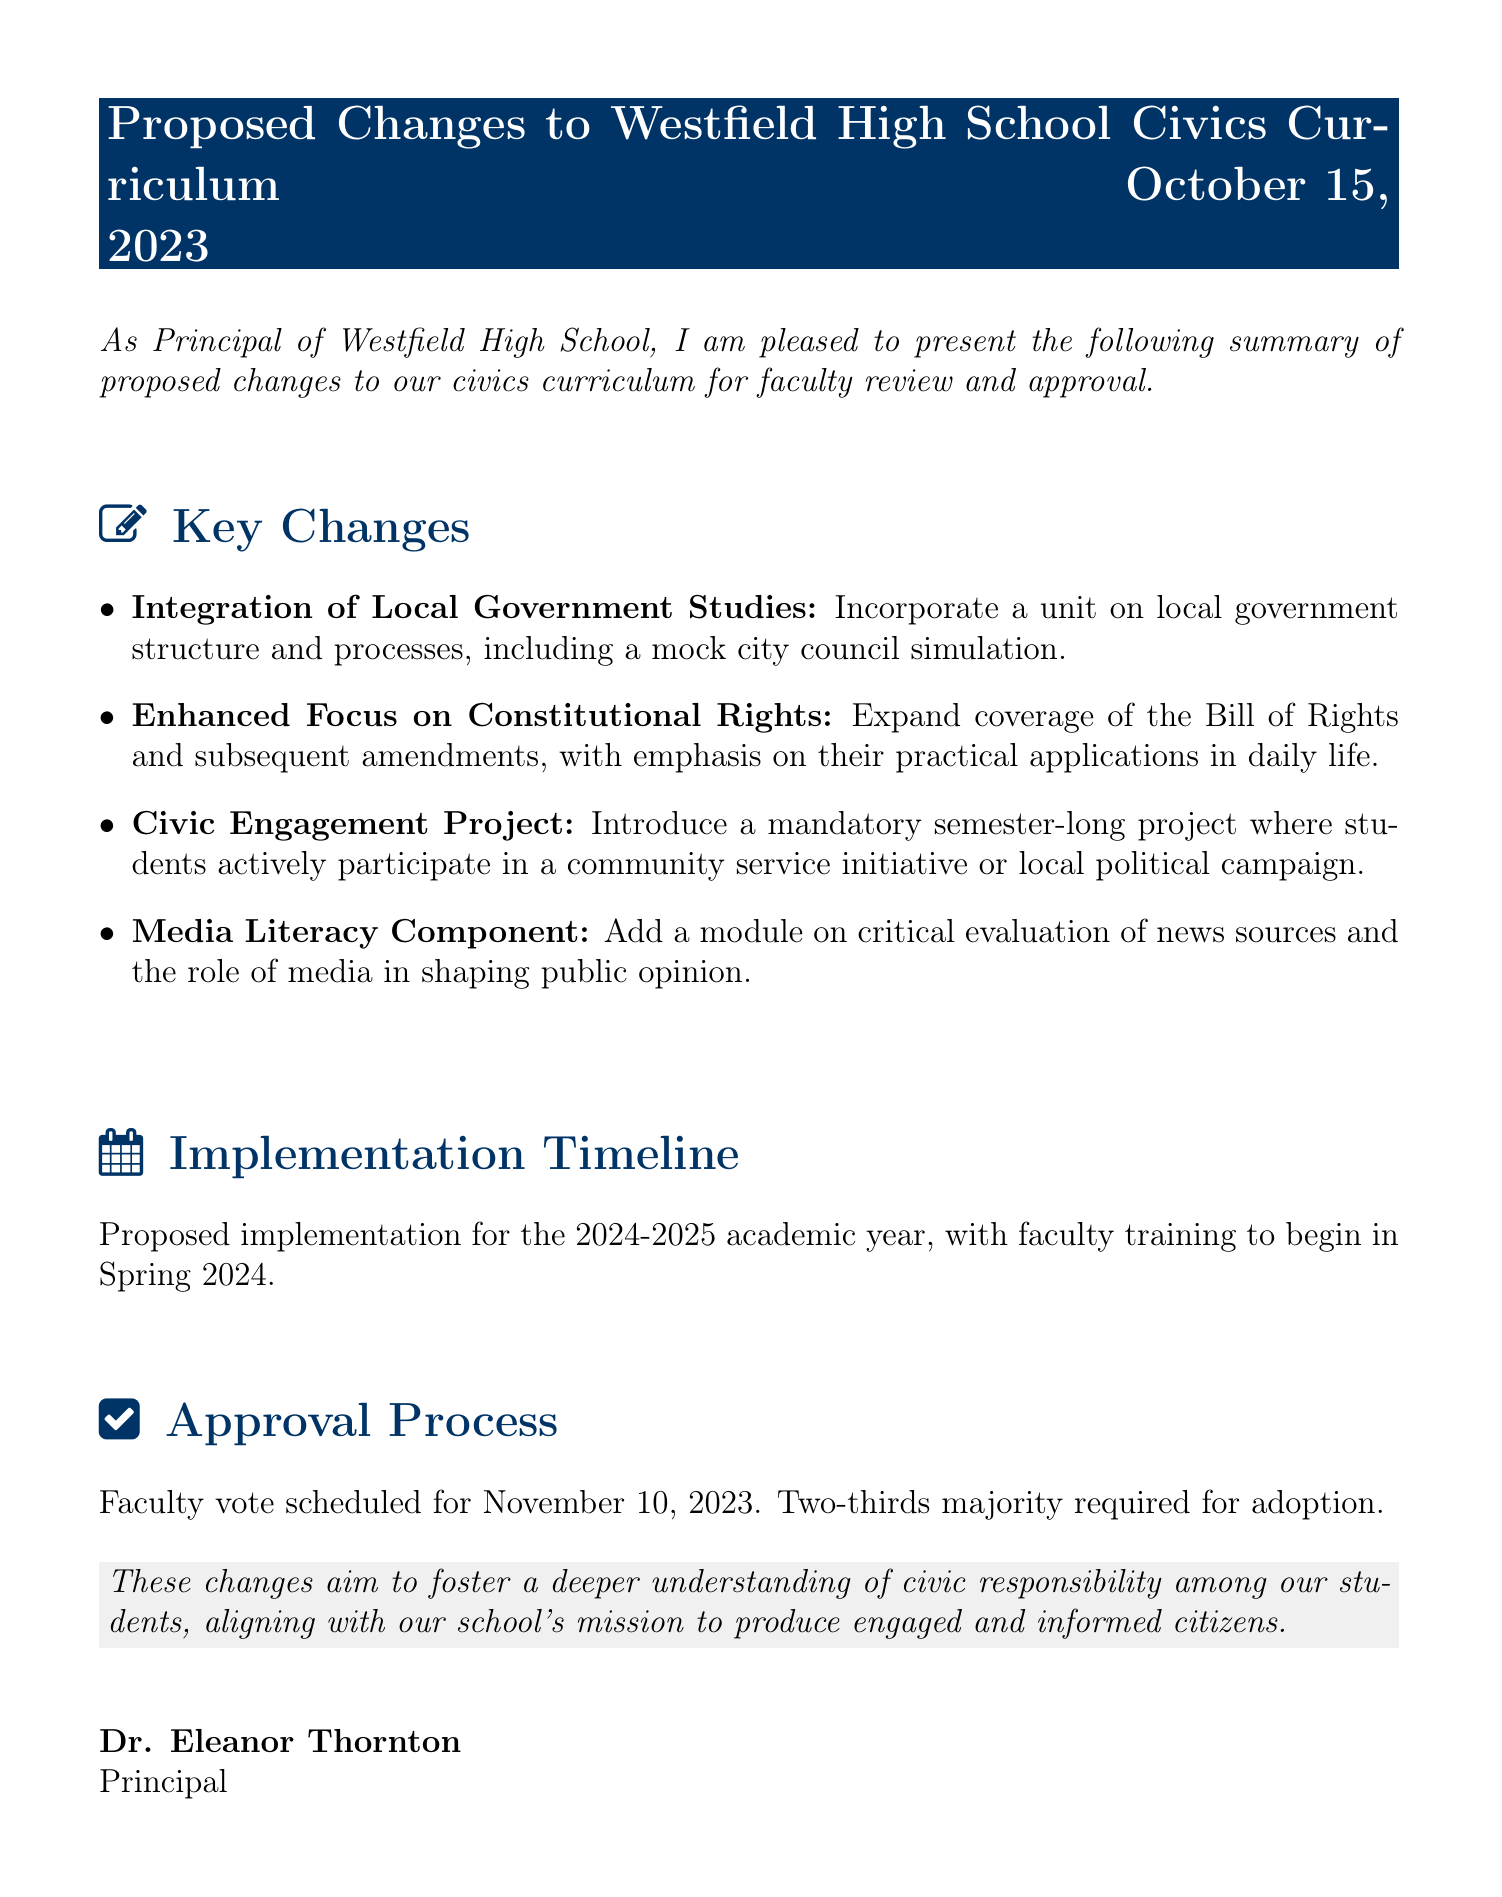What is the date of the proposed changes fax? The date is mentioned in the header of the document, specifying when the changes are presented for review.
Answer: October 15, 2023 What is one key change in the civics curriculum? The document lists several key changes in a bulleted format; one is specifically about local government studies.
Answer: Integration of Local Government Studies When is the faculty vote scheduled? The document clearly states the date for the faculty vote in the approval process section.
Answer: November 10, 2023 What majority is required for adoption? The document specifies the required majority for approval of the proposed changes in the approval process section.
Answer: Two-thirds majority What is the proposed implementation year for the curriculum changes? The implementation year is stated in the implementation timeline section of the document.
Answer: 2024-2025 What component is added for media literacy? The document mentions a specific module that focuses on a particular aspect of media literacy in the key changes section.
Answer: Critical evaluation of news sources What is the focus of the Civic Engagement Project? The document describes the goal of the project, which involves a specific type of participation by students.
Answer: Community service initiative or local political campaign Who is the principal of Westfield High School? The author's identity is provided at the end of the document under the principal's name.
Answer: Dr. Eleanor Thornton 